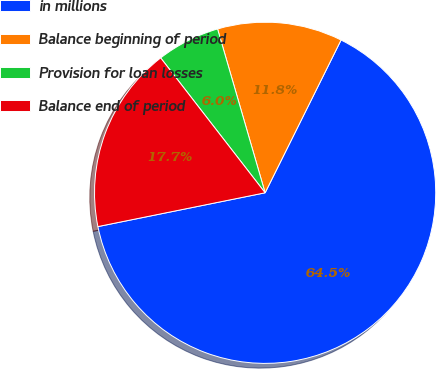Convert chart to OTSL. <chart><loc_0><loc_0><loc_500><loc_500><pie_chart><fcel>in millions<fcel>Balance beginning of period<fcel>Provision for loan losses<fcel>Balance end of period<nl><fcel>64.49%<fcel>11.84%<fcel>5.99%<fcel>17.69%<nl></chart> 